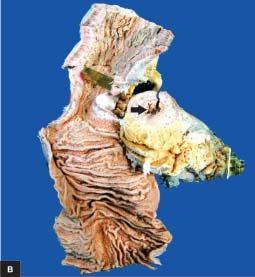what shows segment of thickened wall with narrow lumen which is better appreciated in cross section while intervening areas of the bowel are uninvolved or skipped?
Answer the question using a single word or phrase. Luminal surface of longitudinal cut section 